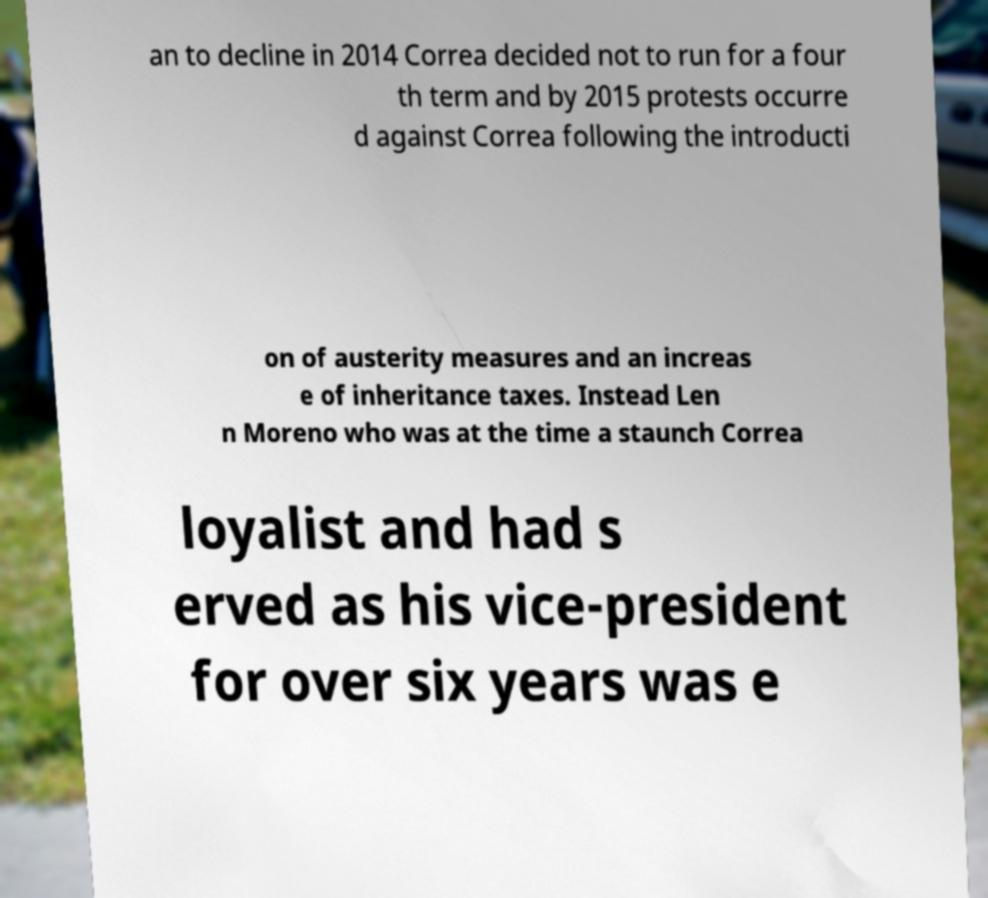What messages or text are displayed in this image? I need them in a readable, typed format. an to decline in 2014 Correa decided not to run for a four th term and by 2015 protests occurre d against Correa following the introducti on of austerity measures and an increas e of inheritance taxes. Instead Len n Moreno who was at the time a staunch Correa loyalist and had s erved as his vice-president for over six years was e 